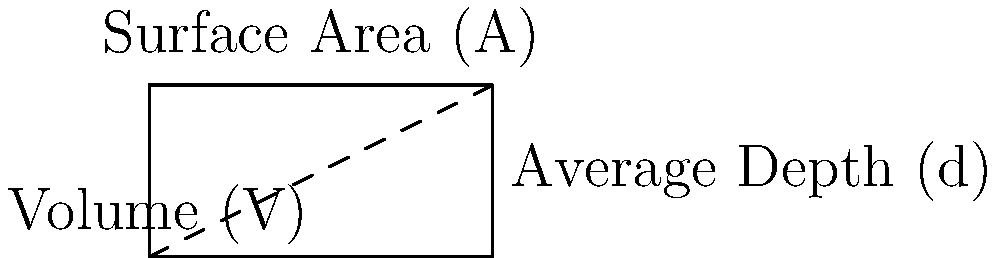As a park ranger at Stark Parks, you need to estimate the volume of water in Sippo Lake for a water quality assessment. Given that the surface area of Sippo Lake is 100 acres and its average depth is 8 feet, calculate the volume of water in the lake in cubic feet. Use the formula $V = A \times d$, where $V$ is volume, $A$ is surface area, and $d$ is average depth. To solve this problem, we'll follow these steps:

1) First, we need to convert the surface area from acres to square feet:
   1 acre = 43,560 square feet
   $A = 100 \text{ acres} \times 43,560 \frac{\text{sq ft}}{\text{acre}} = 4,356,000 \text{ sq ft}$

2) We already have the average depth in feet:
   $d = 8 \text{ ft}$

3) Now we can apply the formula $V = A \times d$:
   $V = 4,356,000 \text{ sq ft} \times 8 \text{ ft}$

4) Calculate the result:
   $V = 34,848,000 \text{ cu ft}$

Therefore, the volume of water in Sippo Lake is 34,848,000 cubic feet.
Answer: 34,848,000 cubic feet 